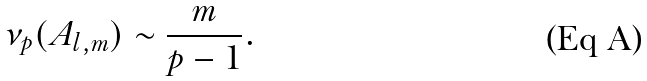Convert formula to latex. <formula><loc_0><loc_0><loc_500><loc_500>\nu _ { p } ( A _ { l , m } ) \sim \frac { m } { p - 1 } .</formula> 